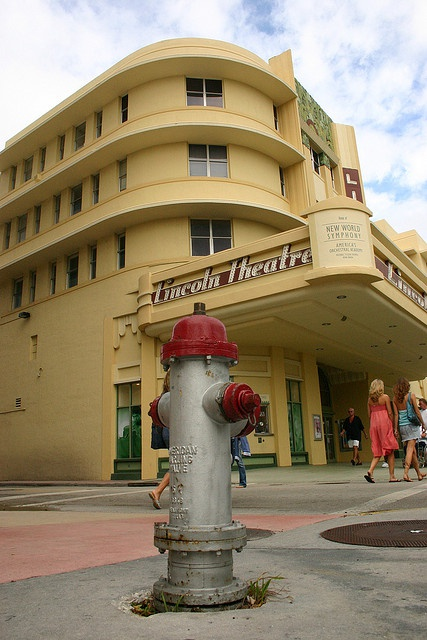Describe the objects in this image and their specific colors. I can see fire hydrant in white, gray, darkgray, black, and maroon tones, people in white, brown, and maroon tones, people in white, maroon, black, gray, and brown tones, people in white, black, maroon, and gray tones, and people in white, black, maroon, gray, and olive tones in this image. 